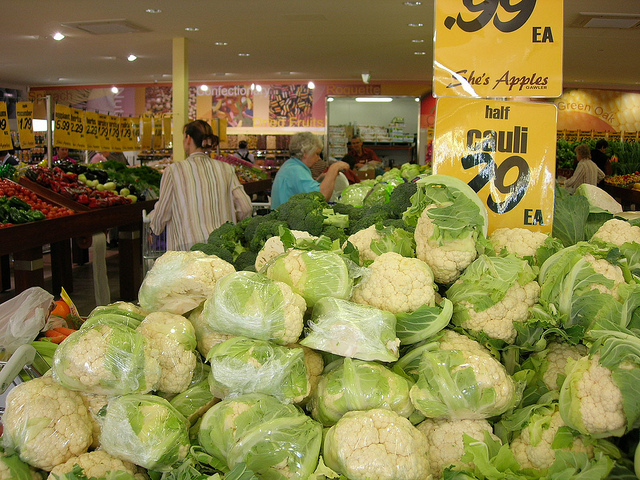Is there any indication of a sale or special offer in this image? Yes, there is a sign right above the cauliflower that indicates there's a special offer where cauliflowers are being sold for 'half price.' 